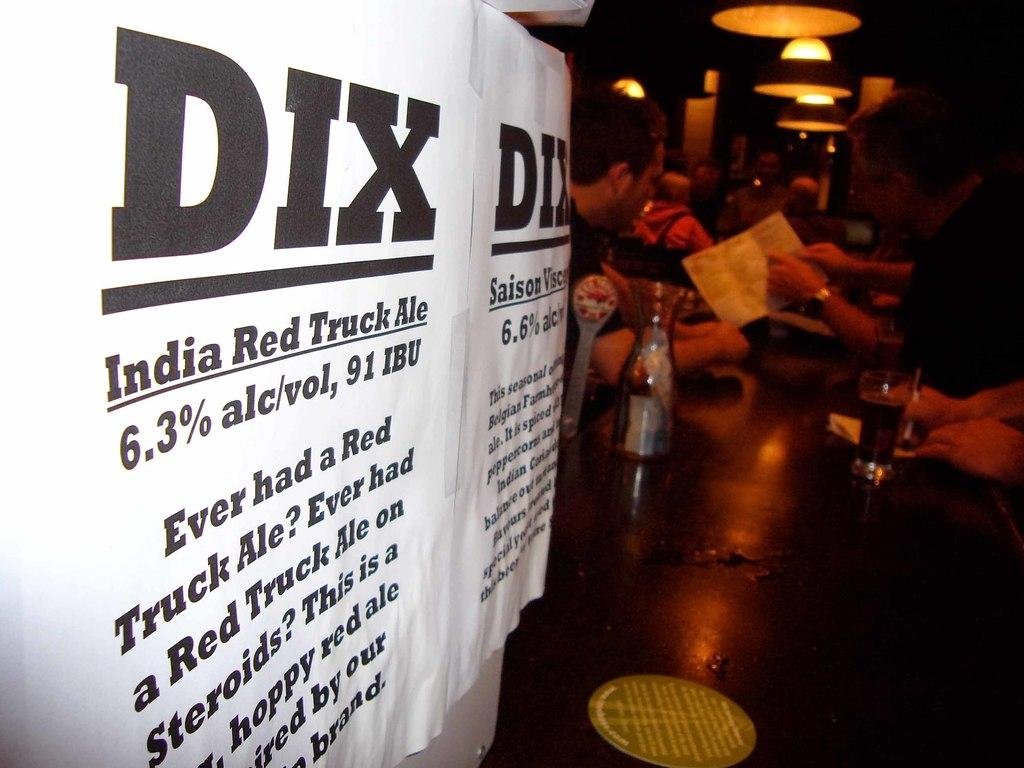<image>
Summarize the visual content of the image. The type of alcohol listed is called India Red Truck Ale 